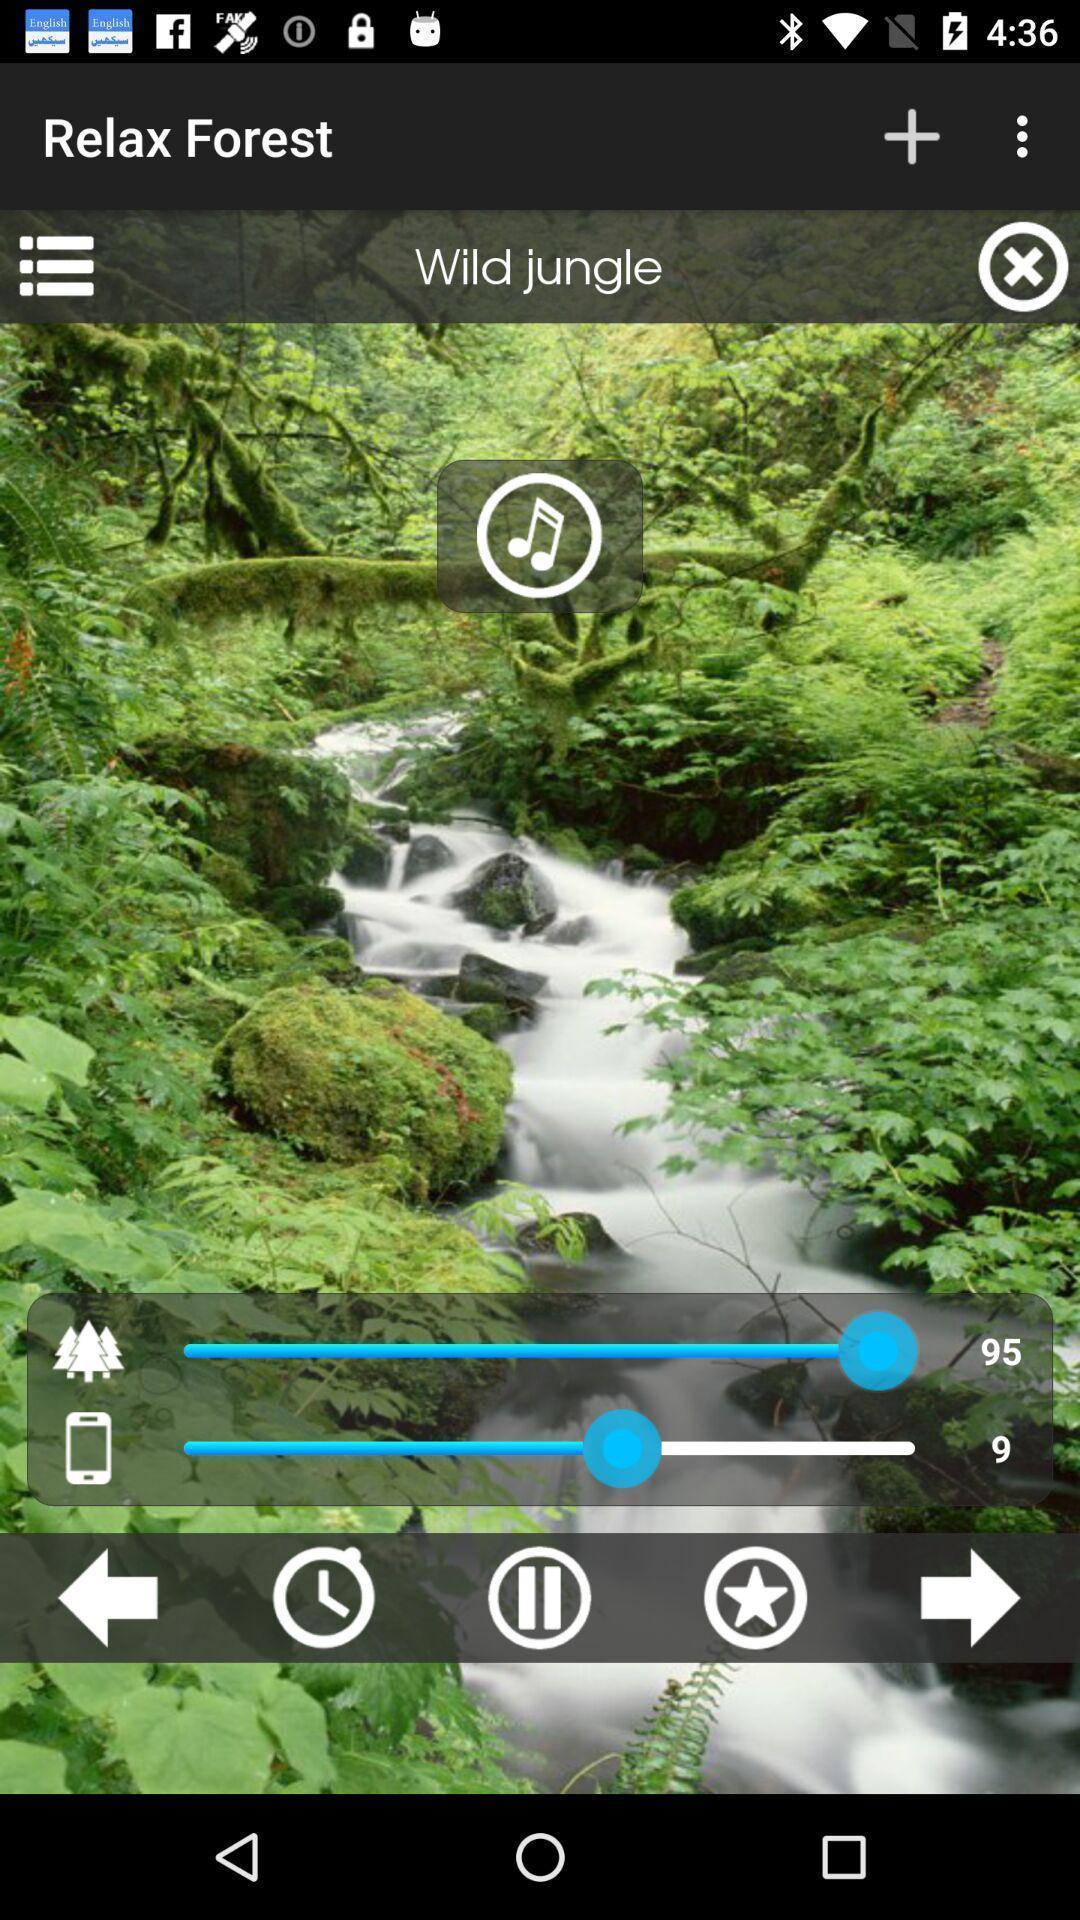Give me a narrative description of this picture. Various options for music player app. 